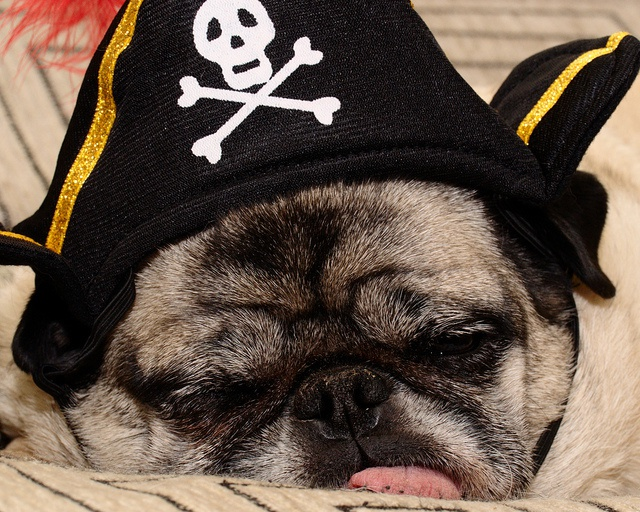Describe the objects in this image and their specific colors. I can see dog in black, salmon, gray, and darkgray tones, dog in salmon, black, darkgray, tan, and gray tones, and couch in salmon, tan, and black tones in this image. 